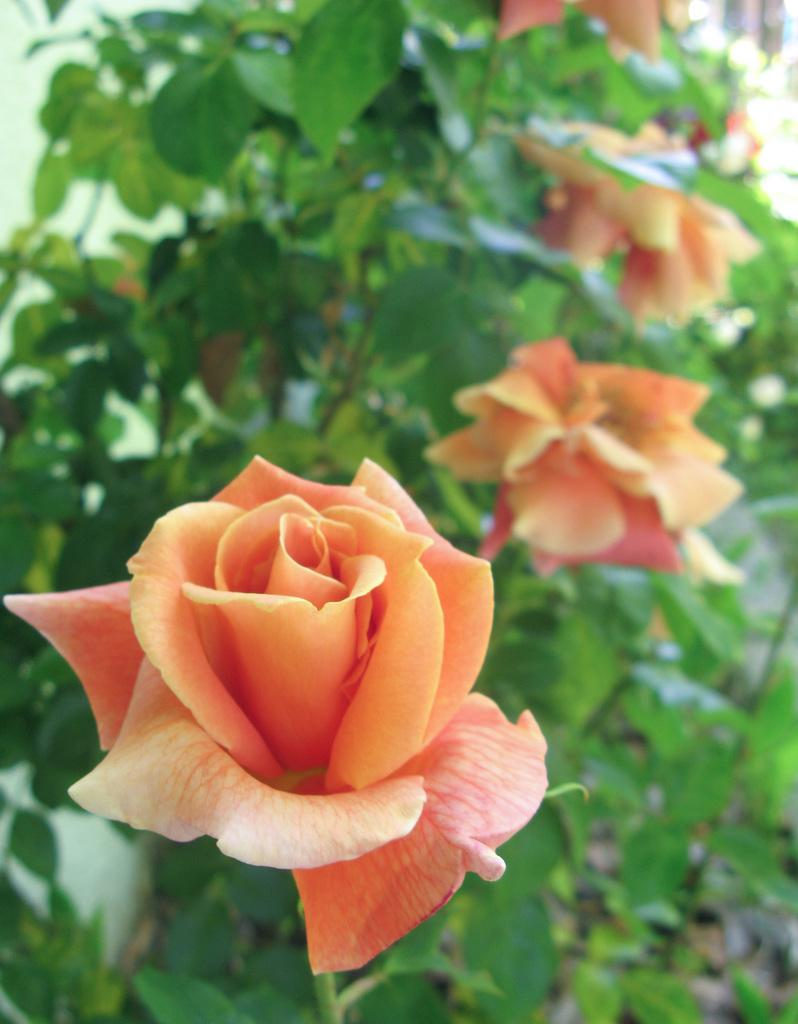What type of plants are in the image? There are rose plants in the image. Where are the rose plants located? The rose plants are on the ground. Can you describe the time of day when the image was likely taken? The image was likely taken during the day. What type of setting might the image depict? The setting may be a garden. What book is the person reading in the image? There is no person or book present in the image; it features rose plants on the ground. 